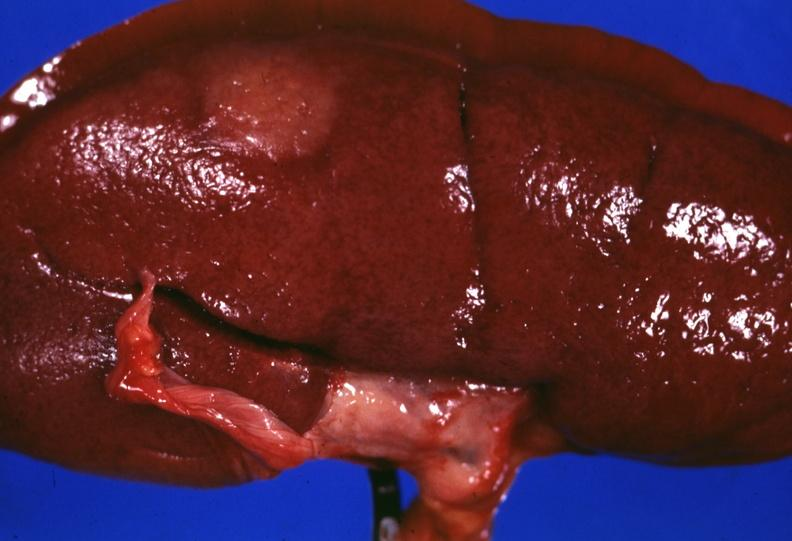how is surface lesion capsule stripped?
Answer the question using a single word or phrase. Unusual 